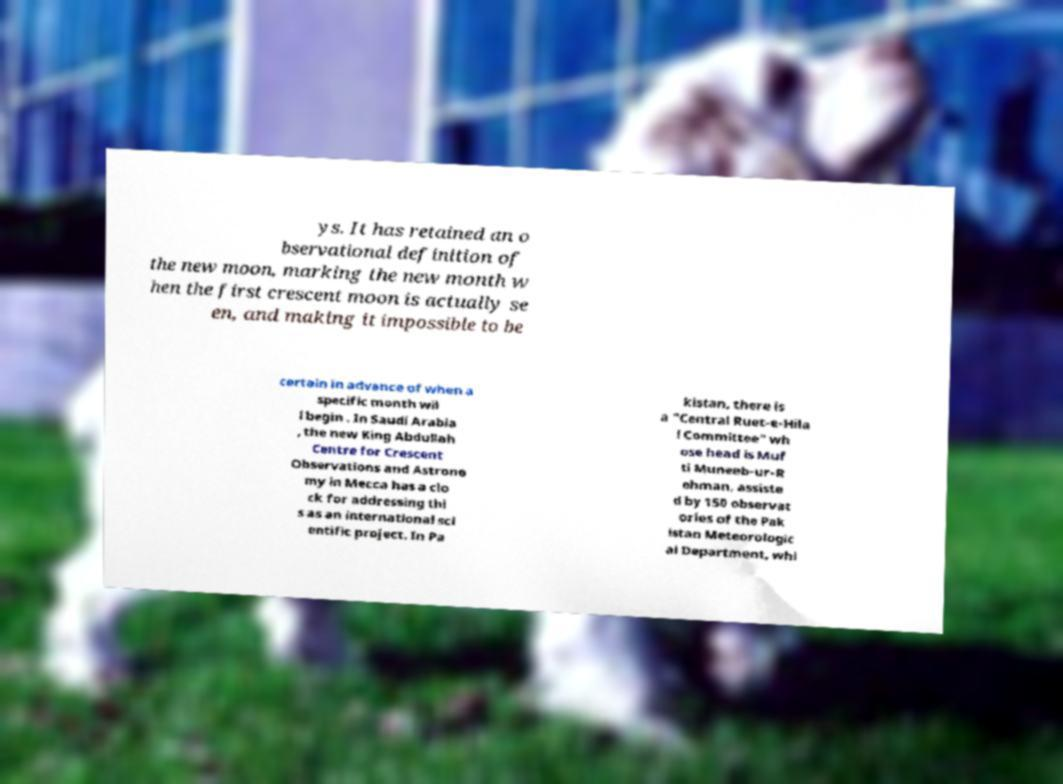Please identify and transcribe the text found in this image. ys. It has retained an o bservational definition of the new moon, marking the new month w hen the first crescent moon is actually se en, and making it impossible to be certain in advance of when a specific month wil l begin . In Saudi Arabia , the new King Abdullah Centre for Crescent Observations and Astrono my in Mecca has a clo ck for addressing thi s as an international sci entific project. In Pa kistan, there is a "Central Ruet-e-Hila l Committee" wh ose head is Muf ti Muneeb-ur-R ehman, assiste d by 150 observat ories of the Pak istan Meteorologic al Department, whi 